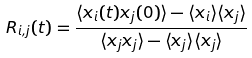<formula> <loc_0><loc_0><loc_500><loc_500>R _ { i , j } ( t ) = \frac { \langle x _ { i } ( t ) x _ { j } ( 0 ) \rangle - \langle x _ { i } \rangle \langle x _ { j } \rangle } { \langle x _ { j } x _ { j } \rangle - \langle x _ { j } \rangle \langle x _ { j } \rangle }</formula> 